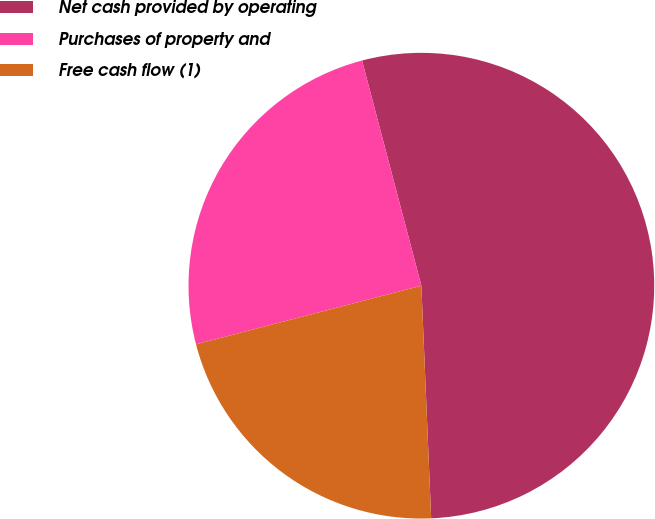Convert chart to OTSL. <chart><loc_0><loc_0><loc_500><loc_500><pie_chart><fcel>Net cash provided by operating<fcel>Purchases of property and<fcel>Free cash flow (1)<nl><fcel>53.43%<fcel>24.95%<fcel>21.62%<nl></chart> 